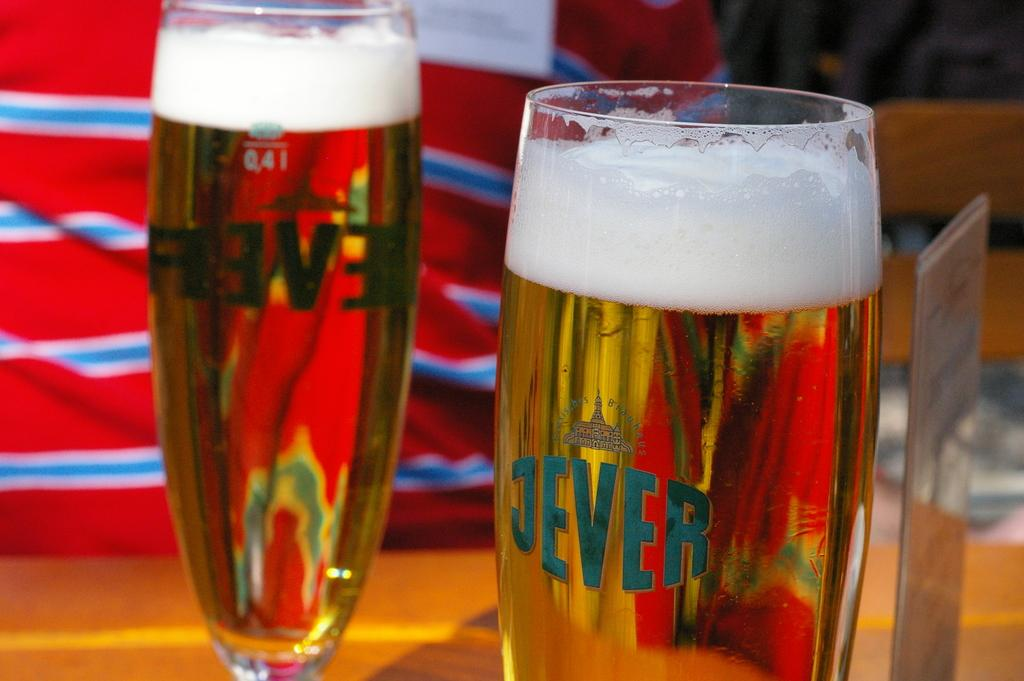<image>
Provide a brief description of the given image. Two glasses of beer have the word Jever printed on them. 